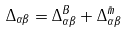<formula> <loc_0><loc_0><loc_500><loc_500>\Delta _ { \alpha \beta } = \Delta _ { \alpha \beta } ^ { B } + \Delta _ { \alpha \beta } ^ { \tilde { m } }</formula> 